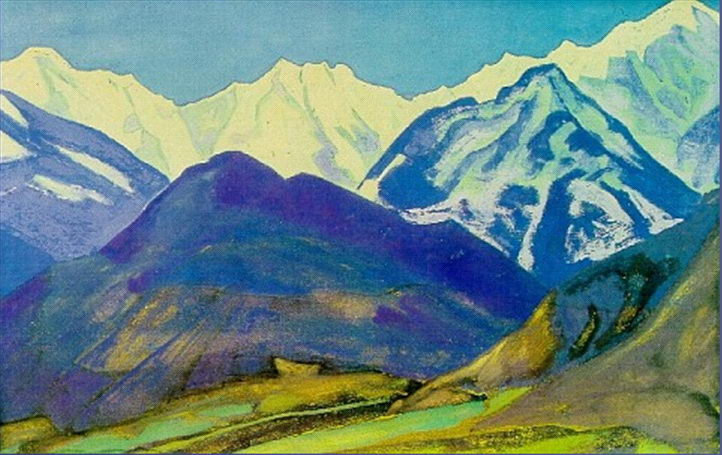Imagine, beyond the mountains, exists a hidden kingdom only accessible by those with a pure heart. Describe this kingdom. Beyond the towering mountains lies a hidden kingdom, untouched by time and only accessible to those of pure heart. This mystical realm is an Eden of endless gardens, with flowers of unimaginable hues and scents that fill the air with a perpetual sense of spring. Waterfalls cascade from crystalline peaks, creating serene lakes and rivers that sparkle under a sun that seems to always shine with a gentle warmth. Majestic, sentient trees whisper ancient wisdom, while friendly, mythical creatures roam freely. The kingdom's architecture blends seamlessly with nature, with homes built into the contours of hills and towers that spiral like vines. Communities live in harmony, celebrating each day with music, dance, and festivity, treasuring the simple, yet profound joys of life. This hidden kingdom is a sanctuary of peace, love, and boundless wonder, a true paradise beyond imagination. 